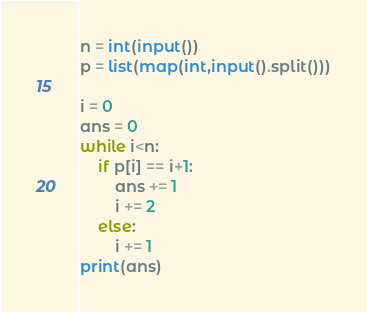Convert code to text. <code><loc_0><loc_0><loc_500><loc_500><_Python_>n = int(input())
p = list(map(int,input().split()))

i = 0
ans = 0
while i<n:
    if p[i] == i+1:
        ans += 1
        i += 2
    else:
        i += 1
print(ans)</code> 